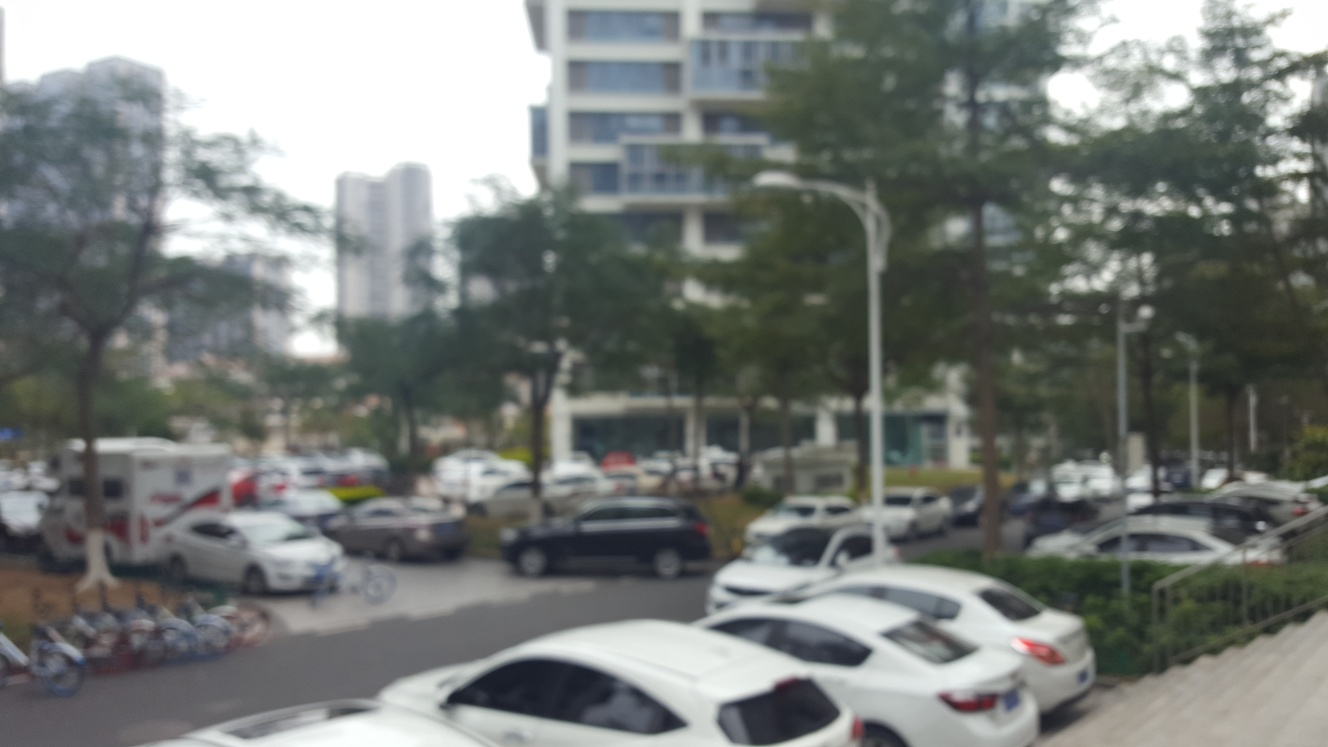Could you suggest ways to improve the clarity of an image like this in the future? To improve clarity in future images, ensuring camera stability is key; using a tripod or a steady surface can help. Adjusting the focus carefully, whether through automatic or manual settings, is also crucial. Additionally, using a higher-quality camera or lens with better resolution and opting for appropriate shutter speed and ISO settings can significantly enhance the sharpness of the image. 